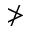<formula> <loc_0><loc_0><loc_500><loc_500>\ngtr</formula> 